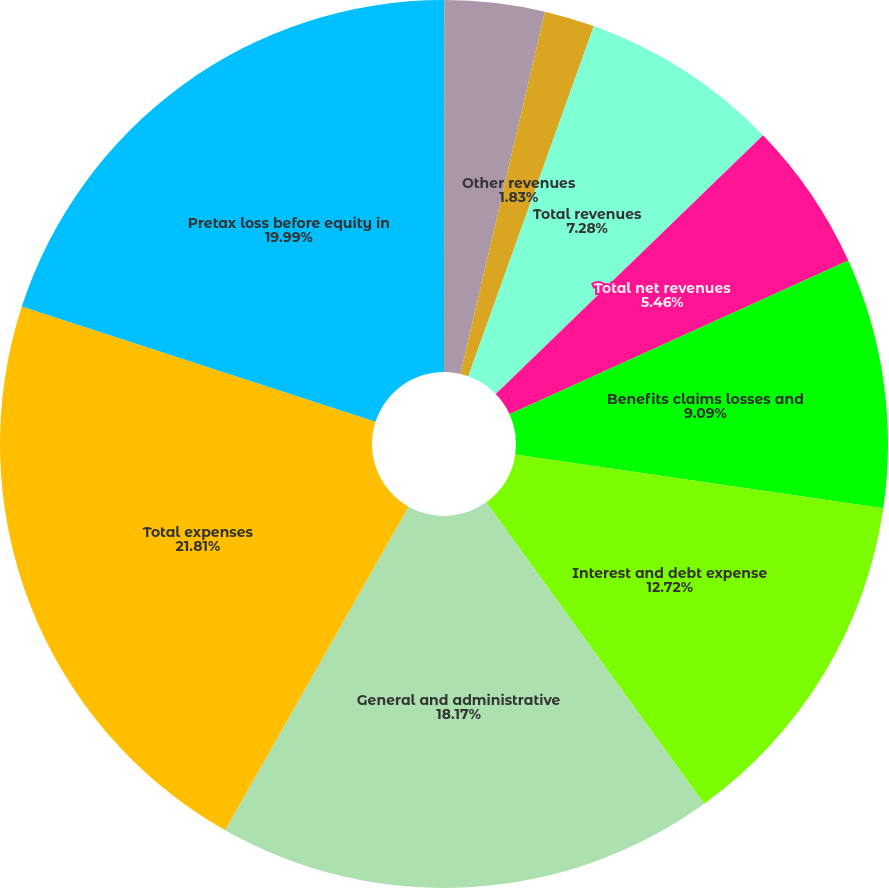Convert chart to OTSL. <chart><loc_0><loc_0><loc_500><loc_500><pie_chart><fcel>Management and financial<fcel>Net investment income<fcel>Other revenues<fcel>Total revenues<fcel>Total net revenues<fcel>Benefits claims losses and<fcel>Interest and debt expense<fcel>General and administrative<fcel>Total expenses<fcel>Pretax loss before equity in<nl><fcel>0.01%<fcel>3.64%<fcel>1.83%<fcel>7.28%<fcel>5.46%<fcel>9.09%<fcel>12.72%<fcel>18.17%<fcel>21.8%<fcel>19.99%<nl></chart> 